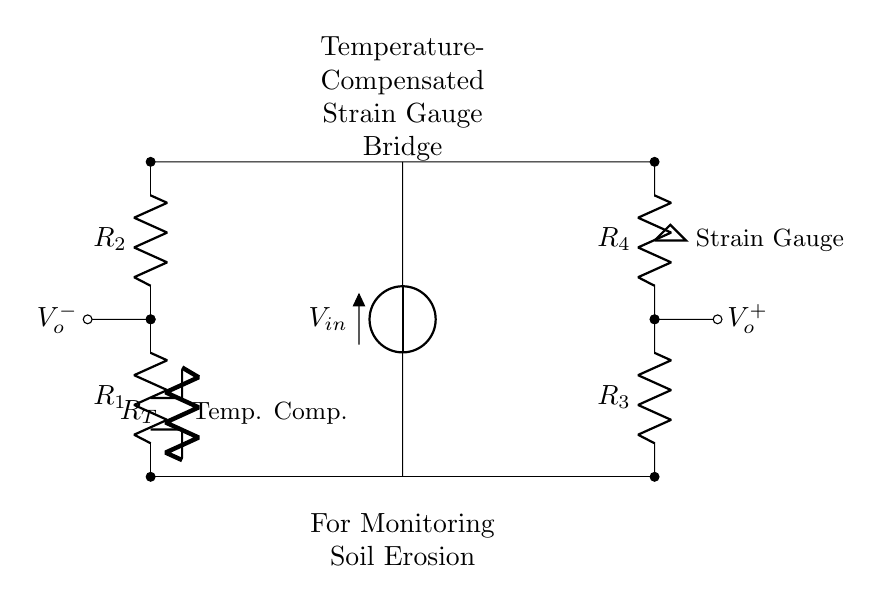What are the resistors labeled as? The resistors in the circuit are labeled as R1, R2, R3, R4, and RT for the temperature compensator.
Answer: R1, R2, R3, R4, RT What is the role of the strain gauge in this bridge circuit? The strain gauge is used to measure deformation in the soil due to erosion, which affects the resistance in the bridge and allows for monitoring changes.
Answer: Measure deformation What is the purpose of the temperature compensation resistor? The temperature compensation resistor (RT) is used to stabilize the readings of the strain gauge by counteracting the effects of temperature changes on resistance.
Answer: Stabilize readings How many branches does the bridge have? The bridge has two branches: one on the left with resistors R1 and R2, and another on the right with resistors R3 and R4.
Answer: Two branches What is the input voltage supplied to the circuit? The input voltage (Vin) does not have a specified numerical value in the diagram, but it is indicated as the voltage source connected vertically.
Answer: Not specified Which side of the bridge outputs the voltage? The output voltage is taken from the nodes marked V_o^- on the left and V_o^+ on the right of the bridge connection.
Answer: V_o^-, V_o^+ What is the primary application of this circuit? The primary application of this circuit is for monitoring soil erosion, as indicated in the annotations at the top of the diagram.
Answer: Monitoring soil erosion 